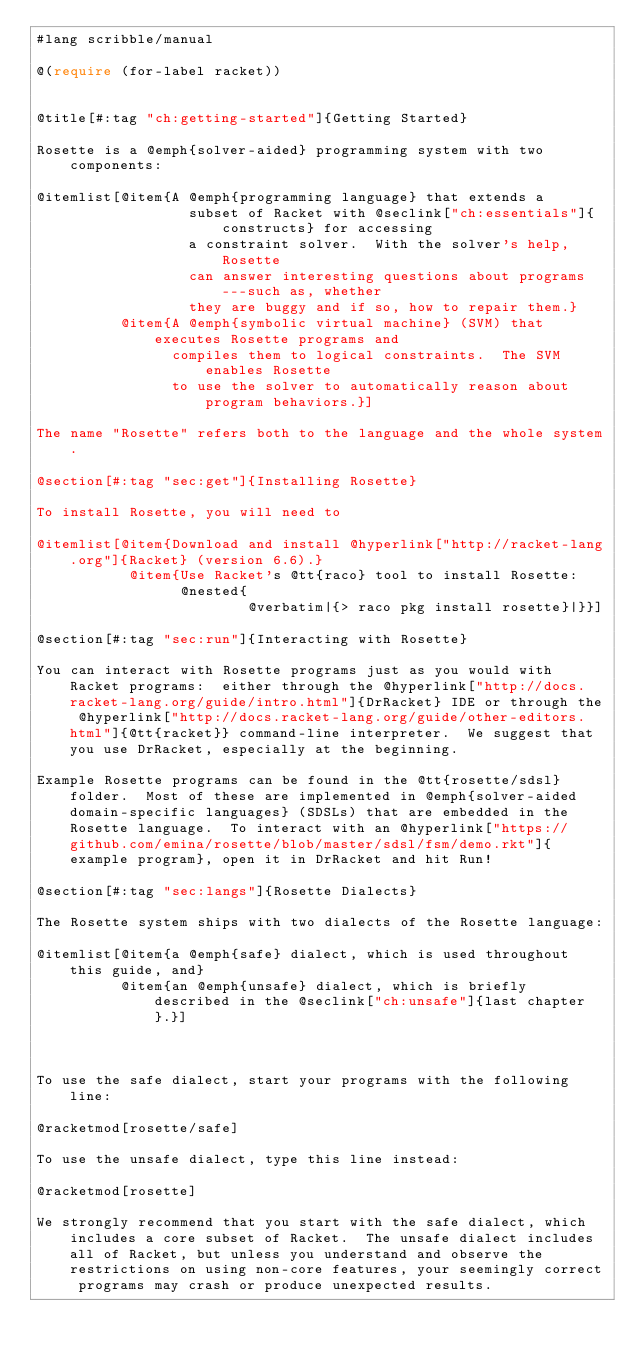Convert code to text. <code><loc_0><loc_0><loc_500><loc_500><_Racket_>#lang scribble/manual

@(require (for-label racket))


@title[#:tag "ch:getting-started"]{Getting Started}

Rosette is a @emph{solver-aided} programming system with two components: 

@itemlist[@item{A @emph{programming language} that extends a  
                  subset of Racket with @seclink["ch:essentials"]{constructs} for accessing 
                  a constraint solver.  With the solver's help, Rosette
                  can answer interesting questions about programs---such as, whether 
                  they are buggy and if so, how to repair them.}
          @item{A @emph{symbolic virtual machine} (SVM) that executes Rosette programs and 
                compiles them to logical constraints.  The SVM enables Rosette 
                to use the solver to automatically reason about program behaviors.}]

The name "Rosette" refers both to the language and the whole system.

@section[#:tag "sec:get"]{Installing Rosette}

To install Rosette, you will need to

@itemlist[@item{Download and install @hyperlink["http://racket-lang.org"]{Racket} (version 6.6).}
           @item{Use Racket's @tt{raco} tool to install Rosette:
                 @nested{
                         @verbatim|{> raco pkg install rosette}|}}]

@section[#:tag "sec:run"]{Interacting with Rosette}

You can interact with Rosette programs just as you would with Racket programs:  either through the @hyperlink["http://docs.racket-lang.org/guide/intro.html"]{DrRacket} IDE or through the @hyperlink["http://docs.racket-lang.org/guide/other-editors.html"]{@tt{racket}} command-line interpreter.  We suggest that you use DrRacket, especially at the beginning.

Example Rosette programs can be found in the @tt{rosette/sdsl} folder.  Most of these are implemented in @emph{solver-aided domain-specific languages} (SDSLs) that are embedded in the Rosette language.  To interact with an @hyperlink["https://github.com/emina/rosette/blob/master/sdsl/fsm/demo.rkt"]{example program}, open it in DrRacket and hit Run!

@section[#:tag "sec:langs"]{Rosette Dialects}

The Rosette system ships with two dialects of the Rosette language: 

@itemlist[@item{a @emph{safe} dialect, which is used throughout this guide, and}
          @item{an @emph{unsafe} dialect, which is briefly described in the @seclink["ch:unsafe"]{last chapter}.}]



To use the safe dialect, start your programs with the following line:

@racketmod[rosette/safe]

To use the unsafe dialect, type this line instead:

@racketmod[rosette]

We strongly recommend that you start with the safe dialect, which includes a core subset of Racket.  The unsafe dialect includes all of Racket, but unless you understand and observe the restrictions on using non-core features, your seemingly correct programs may crash or produce unexpected results.

</code> 